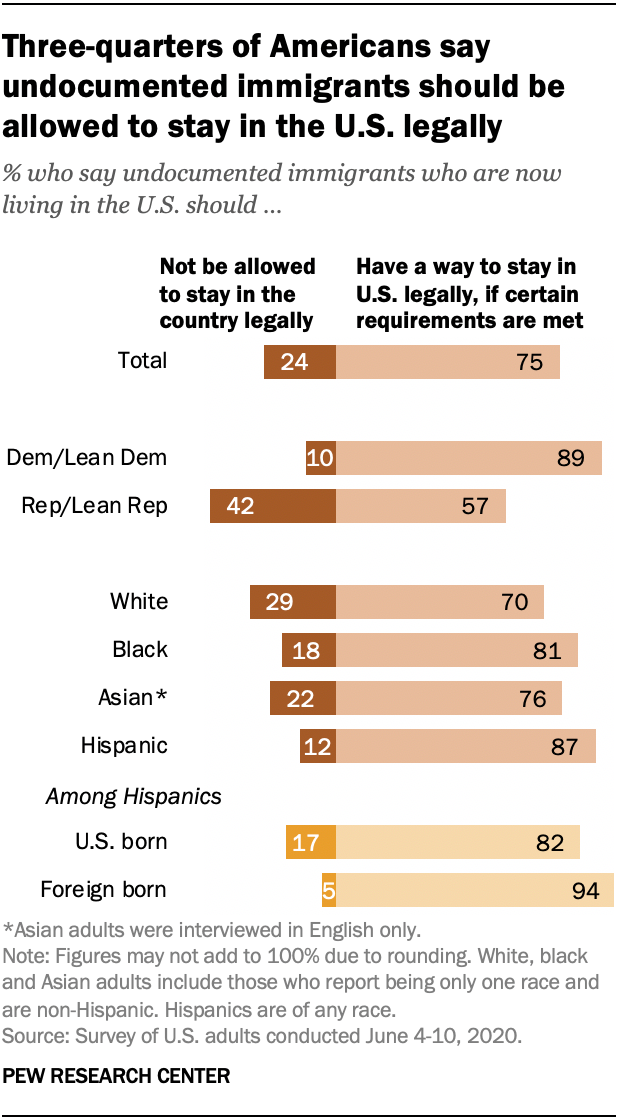Point out several critical features in this image. According to a recent survey, a significant majority of white people in the United States believe that undocumented immigrants who are currently living in the country should not be allowed to stay in the country legally. Of the individuals surveyed who identified as Asian, those who believe that undocumented immigrants who are currently living in the United States should not be allowed to stay in the country legally outnumber those who believe they have a way to stay in the US legally if certain requirements are met by a ratio of 54 to 1. 